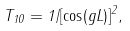<formula> <loc_0><loc_0><loc_500><loc_500>T _ { 1 0 } = 1 / [ \cos ( g L ) ] ^ { 2 } ,</formula> 